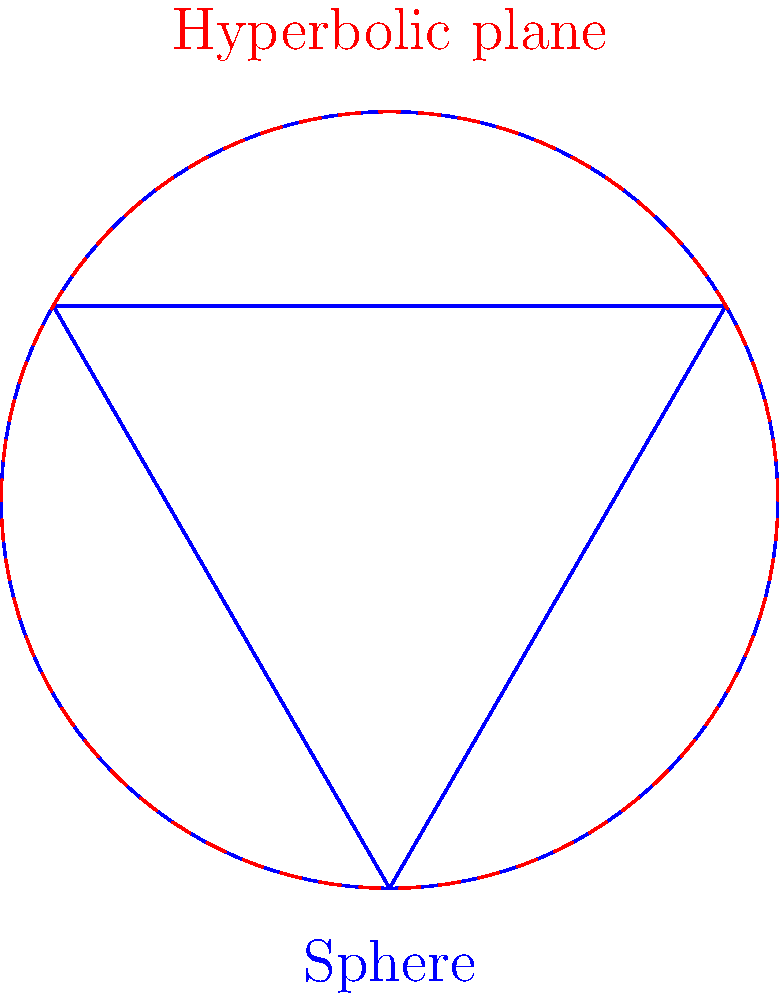As a business analyst applying AI in data cleaning, you're exploring geometric properties in different spaces. Compare the sum of interior angles in a triangle on a sphere and a hyperbolic plane. Which surface has a greater sum of interior angles, and how does this relate to the concept of data dimensionality in AI applications? To answer this question, let's break it down step-by-step:

1. Euclidean geometry (flat plane):
   - In Euclidean geometry, the sum of interior angles of a triangle is always 180°.

2. Spherical geometry:
   - On a sphere, the sum of interior angles of a triangle is always greater than 180°.
   - The formula for the sum of angles in a spherical triangle is: $S = \alpha + \beta + \gamma - 180°$, where $S$ is the spherical excess.
   - The spherical excess is proportional to the area of the triangle on the sphere's surface.

3. Hyperbolic geometry:
   - In hyperbolic geometry, the sum of interior angles of a triangle is always less than 180°.
   - The formula for the sum of angles in a hyperbolic triangle is: $S = 180° - (\alpha + \beta + \gamma)$, where $S$ is the hyperbolic defect.
   - The hyperbolic defect is proportional to the area of the triangle in the hyperbolic plane.

4. Comparison:
   - Sphere: Sum of angles > 180°
   - Euclidean plane: Sum of angles = 180°
   - Hyperbolic plane: Sum of angles < 180°

5. Relation to data dimensionality in AI:
   - In AI and machine learning, data often exists in high-dimensional spaces.
   - As the number of dimensions increases, the geometry of the space can exhibit properties similar to hyperbolic geometry.
   - This phenomenon is known as the "curse of dimensionality" and can affect various aspects of data analysis and machine learning algorithms.
   - Understanding non-Euclidean geometries can provide insights into handling high-dimensional data spaces in AI applications, particularly in data cleaning and preprocessing stages.

Therefore, the sphere has a greater sum of interior angles compared to the hyperbolic plane. This concept relates to data dimensionality in AI by highlighting the importance of understanding geometric properties in different spaces, which can impact how we process and analyze high-dimensional data in machine learning and data cleaning tasks.
Answer: Sphere; relates to high-dimensional data spaces in AI. 